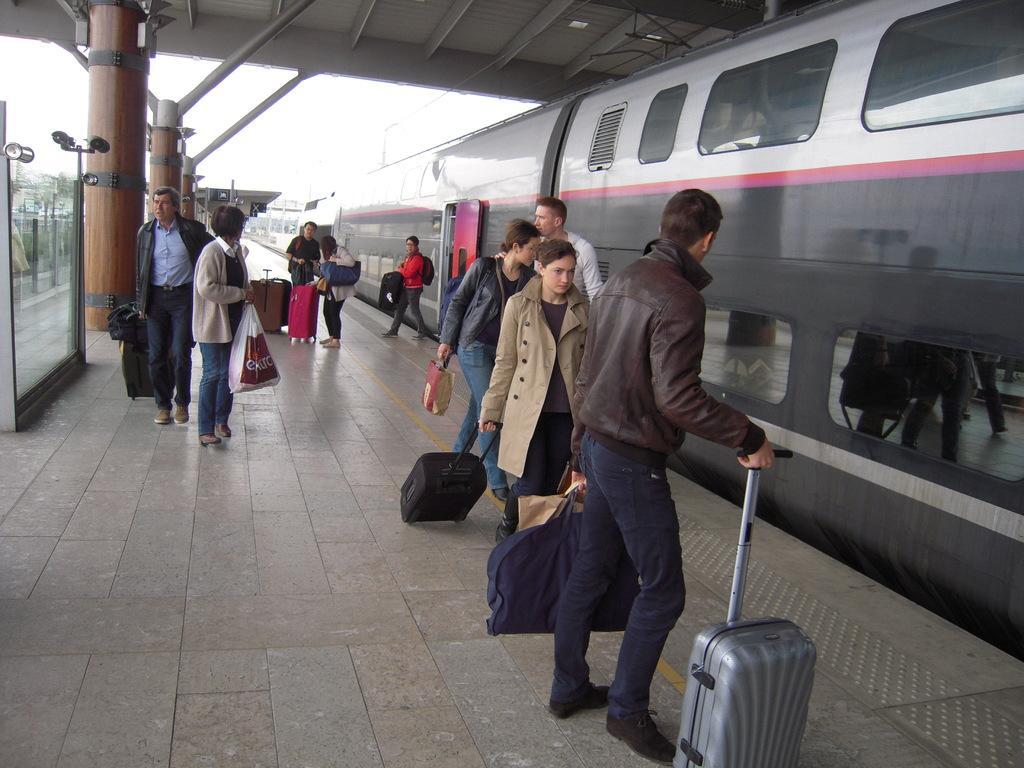How would you summarize this image in a sentence or two? In the middle of the image few people are walking on a platform. Behind them there is a train. At the top of the image there is a roof. Top left side of the image there is a sky and there is a fencing. 